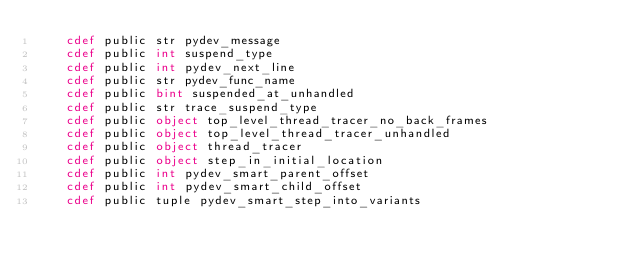<code> <loc_0><loc_0><loc_500><loc_500><_Cython_>    cdef public str pydev_message
    cdef public int suspend_type
    cdef public int pydev_next_line
    cdef public str pydev_func_name
    cdef public bint suspended_at_unhandled
    cdef public str trace_suspend_type
    cdef public object top_level_thread_tracer_no_back_frames
    cdef public object top_level_thread_tracer_unhandled
    cdef public object thread_tracer
    cdef public object step_in_initial_location
    cdef public int pydev_smart_parent_offset
    cdef public int pydev_smart_child_offset
    cdef public tuple pydev_smart_step_into_variants</code> 